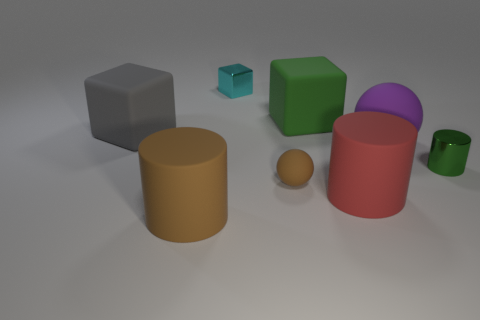The large matte cube to the left of the large matte block that is behind the big gray object is what color?
Offer a very short reply. Gray. What number of other objects are the same color as the tiny metallic cylinder?
Provide a short and direct response. 1. How many objects are big cyan rubber cylinders or metallic things on the left side of the tiny green metal object?
Your response must be concise. 1. There is a large block that is to the right of the tiny metal block; what is its color?
Your answer should be very brief. Green. The big green object has what shape?
Give a very brief answer. Cube. What is the material of the big cube behind the gray rubber block that is behind the big red rubber thing?
Your answer should be compact. Rubber. How many other objects are there of the same material as the large purple ball?
Provide a short and direct response. 5. What material is the green object that is the same size as the brown cylinder?
Your answer should be compact. Rubber. Is the number of things that are to the right of the big red matte cylinder greater than the number of tiny brown objects left of the tiny cyan shiny object?
Your response must be concise. Yes. Is there another shiny thing of the same shape as the large gray object?
Offer a very short reply. Yes. 